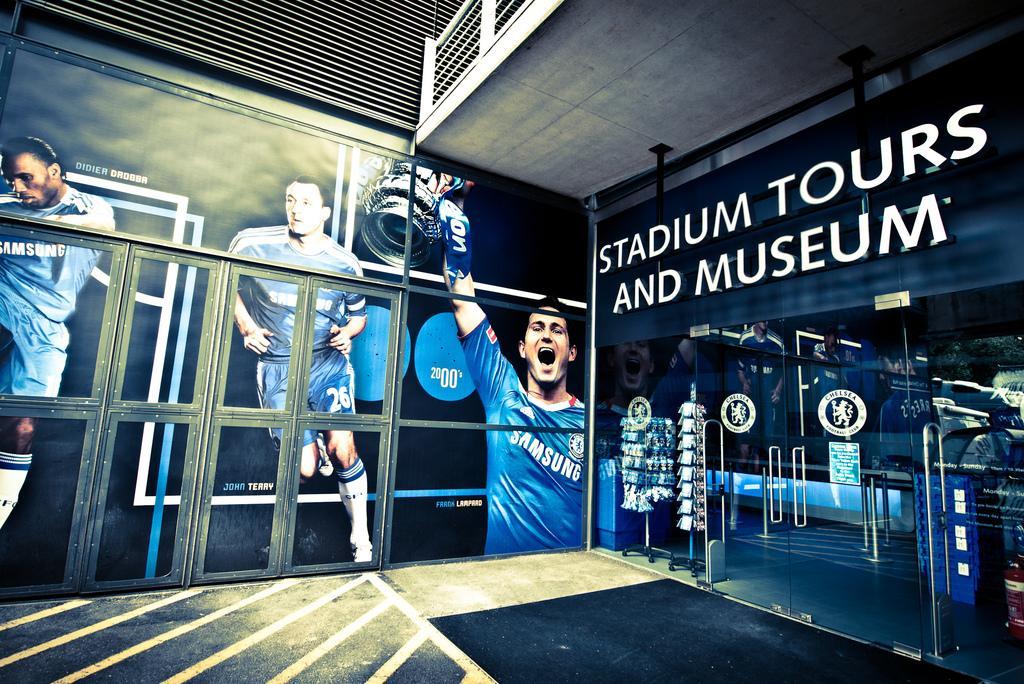Please provide a concise description of this image. In this image I see the posters over here on which there are pictures of 3 persons and I see that this man is holding a trophy is in his hand and I see the doors over here and I see the logos on it and I see something is written over here and I see the path. 